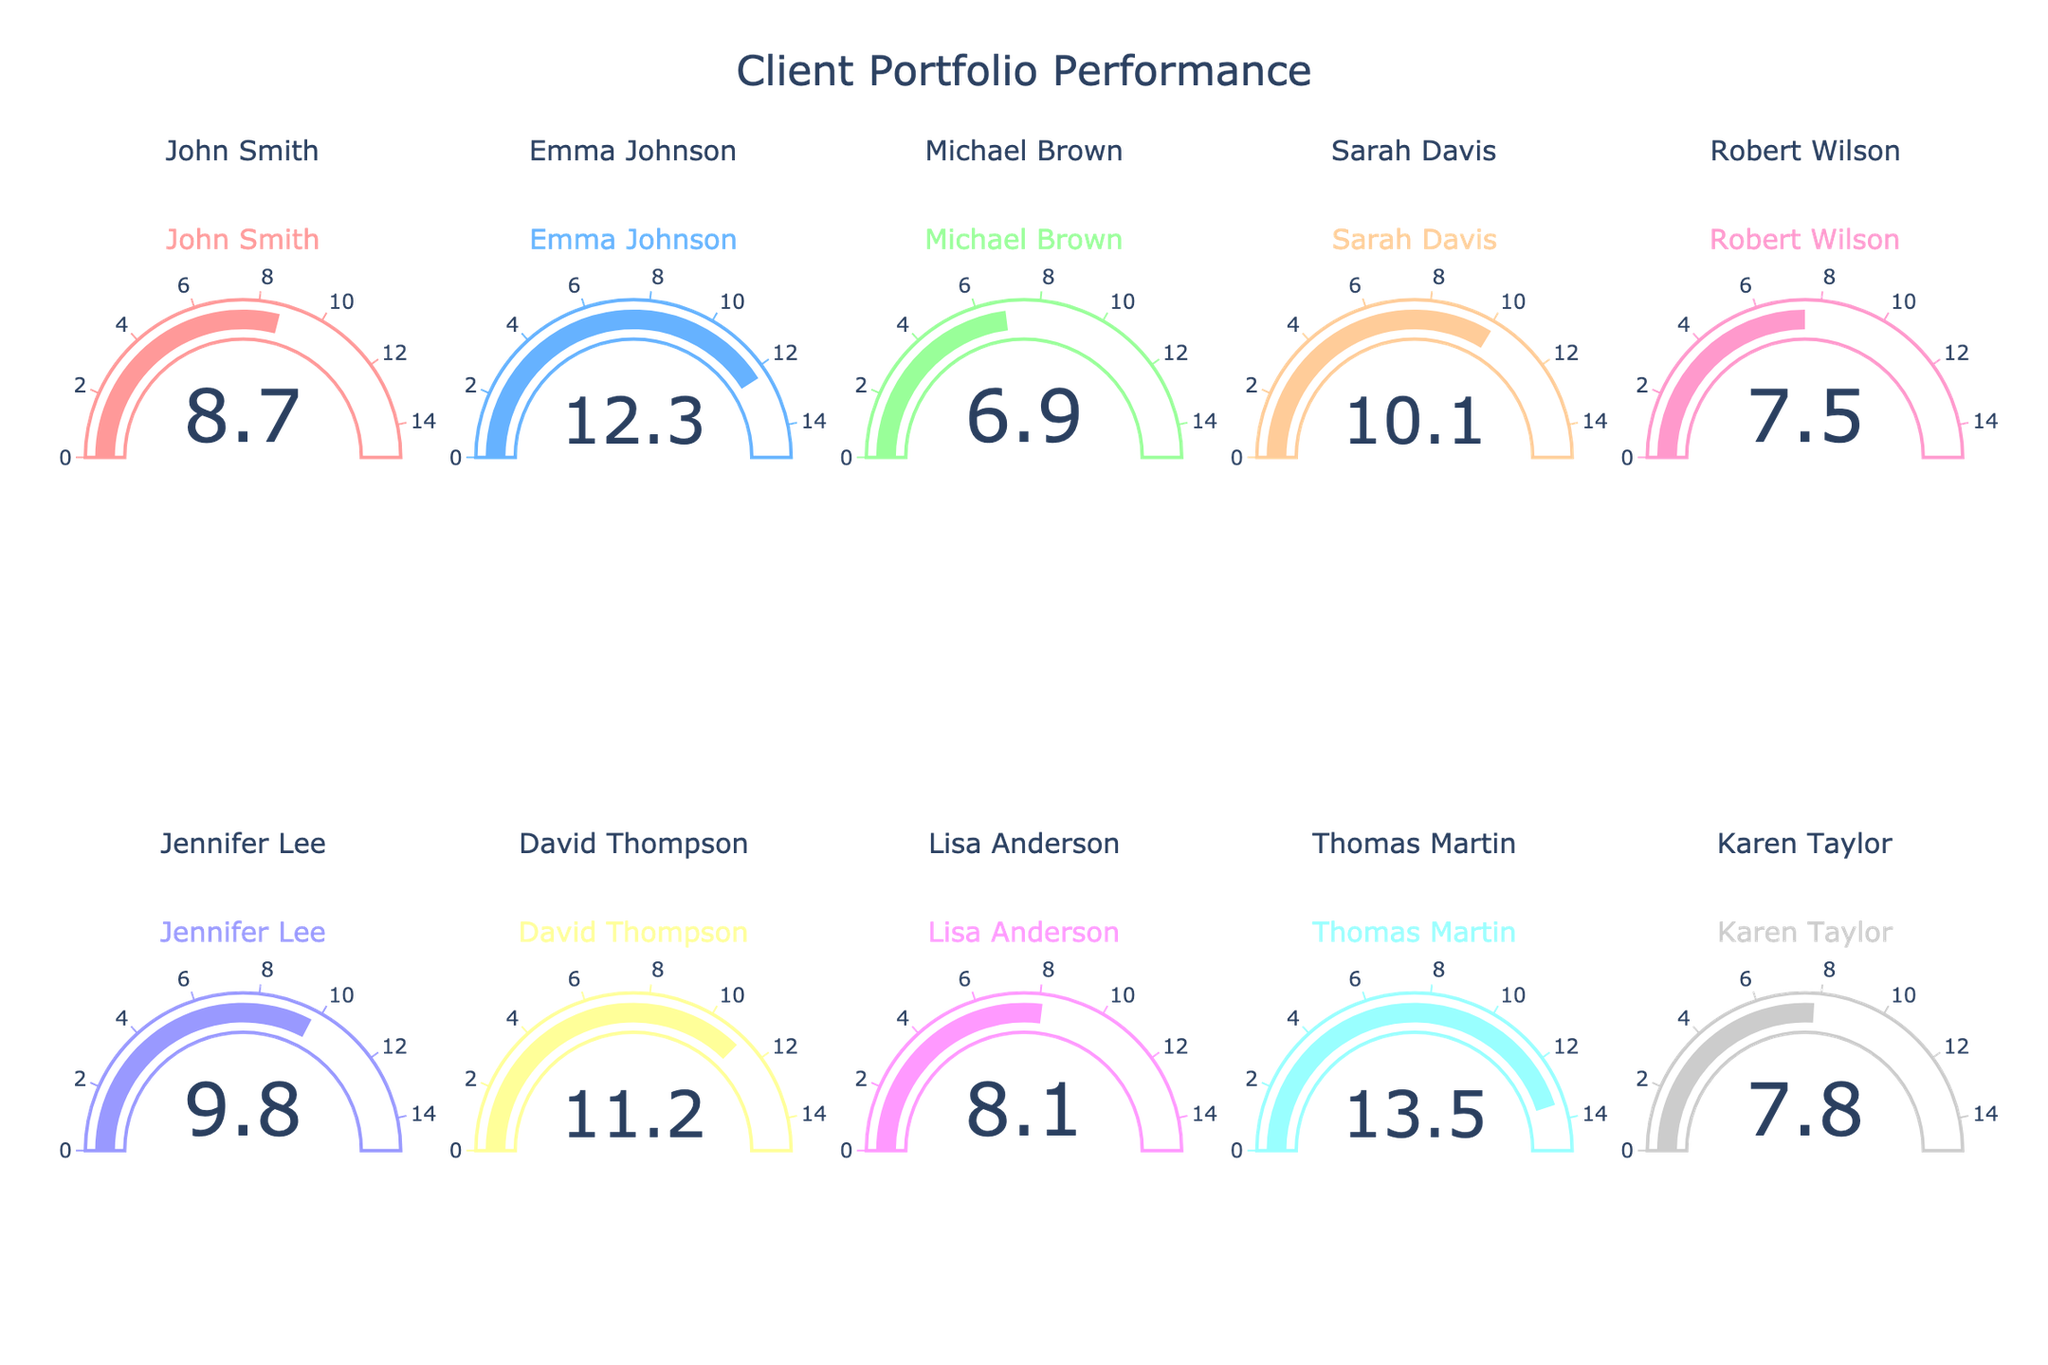Which client's portfolio performance is the highest? The gauges indicate the performance values for each client. By examining the chart, Thomas Martin's portfolio has the highest value at 13.5%.
Answer: Thomas Martin Which client has the second-highest portfolio performance? By looking at the gauges, the second highest value after Thomas Martin's 13.5% is Emma Johnson's at 12.3%.
Answer: Emma Johnson What is the average portfolio performance of all clients? Adding all portfolio performances (8.7 + 12.3 + 6.9 + 10.1 + 7.5 + 9.8 + 11.2 + 8.1 + 13.5 + 7.8) equals 95.9. Dividing by the number of clients (10) gives the average: 95.9 / 10 = 9.59%.
Answer: 9.59% Which client's portfolio performance is closest to the average? The average portfolio performance is 9.59%. The closest value to this average in the chart is Jennifer Lee's at 9.8%.
Answer: Jennifer Lee How many clients have a portfolio performance of above 10%? From the gauges, the clients with above 10% are Emma Johnson (12.3), Sarah Davis (10.1), David Thompson (11.2), and Thomas Martin (13.5). Therefore, 4 clients have a performance above 10%.
Answer: 4 What's the median portfolio performance of all clients? To find the median, first list the performances in ascending order: 6.9, 7.5, 7.8, 8.1, 8.7, 9.8, 10.1, 11.2, 12.3, 13.5. Since there are 10 values, the median is the average of the 5th and 6th values: (8.7+9.8) / 2 = 9.25%.
Answer: 9.25% What is the difference between the highest and lowest portfolio performances? The highest portfolio performance is Thomas Martin's at 13.5%, and the lowest is Michael Brown's at 6.9%. The difference is 13.5 - 6.9 = 6.6%.
Answer: 6.6% Which two clients' portfolio performances are closest to each other? By observing the gauges, the closest performances are Robert Wilson (7.5%) and Karen Taylor (7.8%) with a difference of 0.3%.
Answer: Robert Wilson and Karen Taylor What is the range of the portfolio performances? The range is the difference between the highest and lowest performances. The highest is 13.5% (Thomas Martin) and the lowest is 6.9% (Michael Brown), so the range is 13.5 - 6.9 = 6.6%.
Answer: 6.6% Are there more clients with a portfolio performance above 8% or below 8%? From the gauges, the clients above 8% are John Smith (8.7%), Emma Johnson (12.3%), Sarah Davis (10.1%), Jennifer Lee (9.8%), David Thompson (11.2%), and Thomas Martin (13.5%), Lisa Anderson (8.1%). Those below 8% are Michael Brown (6.9%), Robert Wilson (7.5%), and Karen Taylor (7.8%). More clients have a portfolio above 8%.
Answer: Above 8% 